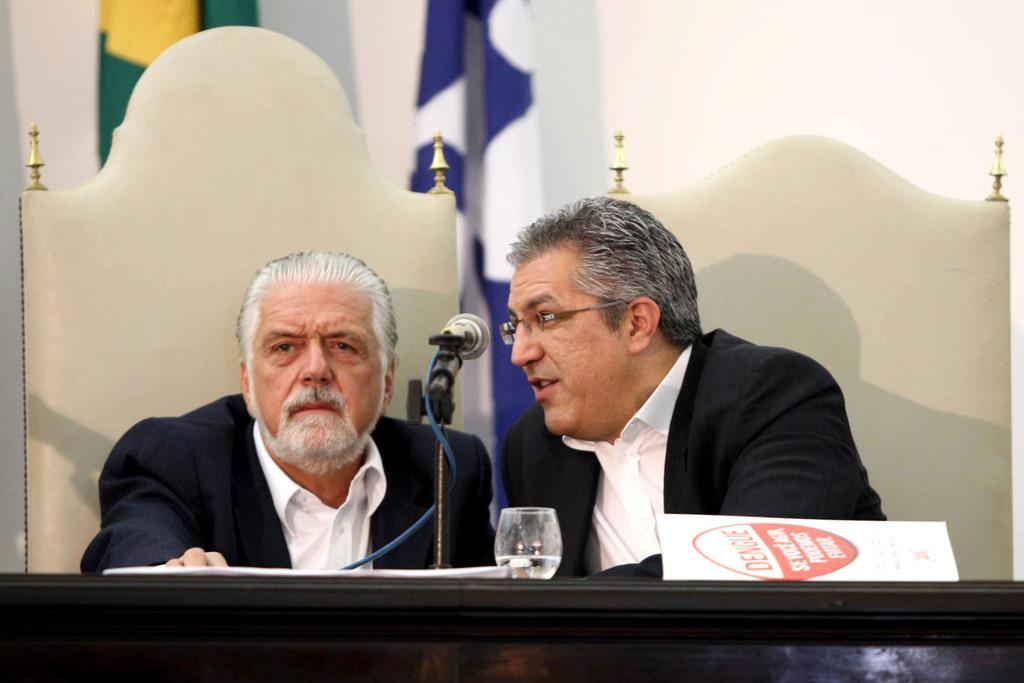How many people are in the image? There are two men in the image. What are the men doing in the image? The men are seated on chairs in the image. What object is in front of the men? There is a mic in front of the men. What is placed between the men and the mic? There is a table in front of the men. What can be seen at the top of the image? There are flags at the top side of the image. What type of shoe is the man wearing on his right foot in the image? There is no information about shoes or feet in the image, as it focuses on the men, their chairs, the mic, the table, and the flags. 